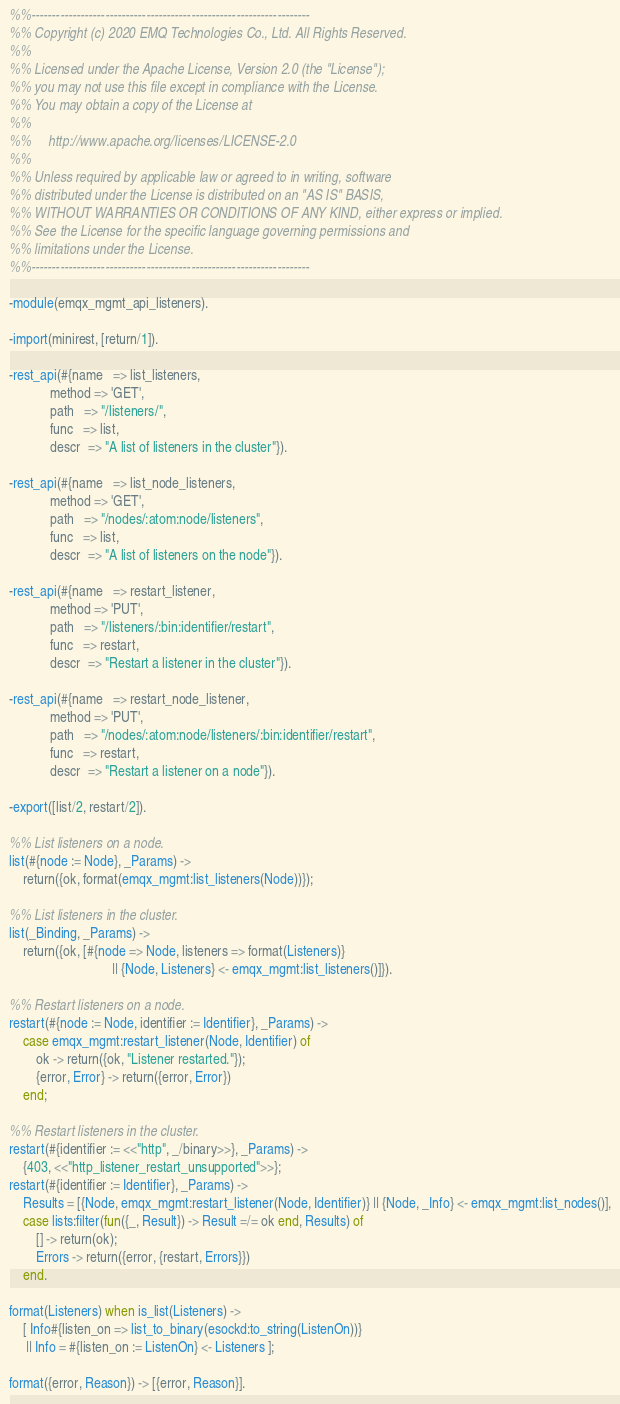Convert code to text. <code><loc_0><loc_0><loc_500><loc_500><_Erlang_>%%--------------------------------------------------------------------
%% Copyright (c) 2020 EMQ Technologies Co., Ltd. All Rights Reserved.
%%
%% Licensed under the Apache License, Version 2.0 (the "License");
%% you may not use this file except in compliance with the License.
%% You may obtain a copy of the License at
%%
%%     http://www.apache.org/licenses/LICENSE-2.0
%%
%% Unless required by applicable law or agreed to in writing, software
%% distributed under the License is distributed on an "AS IS" BASIS,
%% WITHOUT WARRANTIES OR CONDITIONS OF ANY KIND, either express or implied.
%% See the License for the specific language governing permissions and
%% limitations under the License.
%%--------------------------------------------------------------------

-module(emqx_mgmt_api_listeners).

-import(minirest, [return/1]).

-rest_api(#{name   => list_listeners,
            method => 'GET',
            path   => "/listeners/",
            func   => list,
            descr  => "A list of listeners in the cluster"}).

-rest_api(#{name   => list_node_listeners,
            method => 'GET',
            path   => "/nodes/:atom:node/listeners",
            func   => list,
            descr  => "A list of listeners on the node"}).

-rest_api(#{name   => restart_listener,
            method => 'PUT',
            path   => "/listeners/:bin:identifier/restart",
            func   => restart,
            descr  => "Restart a listener in the cluster"}).

-rest_api(#{name   => restart_node_listener,
            method => 'PUT',
            path   => "/nodes/:atom:node/listeners/:bin:identifier/restart",
            func   => restart,
            descr  => "Restart a listener on a node"}).

-export([list/2, restart/2]).

%% List listeners on a node.
list(#{node := Node}, _Params) ->
    return({ok, format(emqx_mgmt:list_listeners(Node))});

%% List listeners in the cluster.
list(_Binding, _Params) ->
    return({ok, [#{node => Node, listeners => format(Listeners)}
                              || {Node, Listeners} <- emqx_mgmt:list_listeners()]}).

%% Restart listeners on a node.
restart(#{node := Node, identifier := Identifier}, _Params) ->
    case emqx_mgmt:restart_listener(Node, Identifier) of
        ok -> return({ok, "Listener restarted."});
        {error, Error} -> return({error, Error})
    end;

%% Restart listeners in the cluster.
restart(#{identifier := <<"http", _/binary>>}, _Params) ->
    {403, <<"http_listener_restart_unsupported">>};
restart(#{identifier := Identifier}, _Params) ->
    Results = [{Node, emqx_mgmt:restart_listener(Node, Identifier)} || {Node, _Info} <- emqx_mgmt:list_nodes()],
    case lists:filter(fun({_, Result}) -> Result =/= ok end, Results) of
        [] -> return(ok);
        Errors -> return({error, {restart, Errors}})
    end.

format(Listeners) when is_list(Listeners) ->
    [ Info#{listen_on => list_to_binary(esockd:to_string(ListenOn))}
     || Info = #{listen_on := ListenOn} <- Listeners ];

format({error, Reason}) -> [{error, Reason}].

</code> 